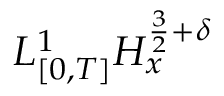<formula> <loc_0><loc_0><loc_500><loc_500>L _ { [ 0 , T ] } ^ { 1 } H _ { x } ^ { \frac { 3 } { 2 } + \delta }</formula> 